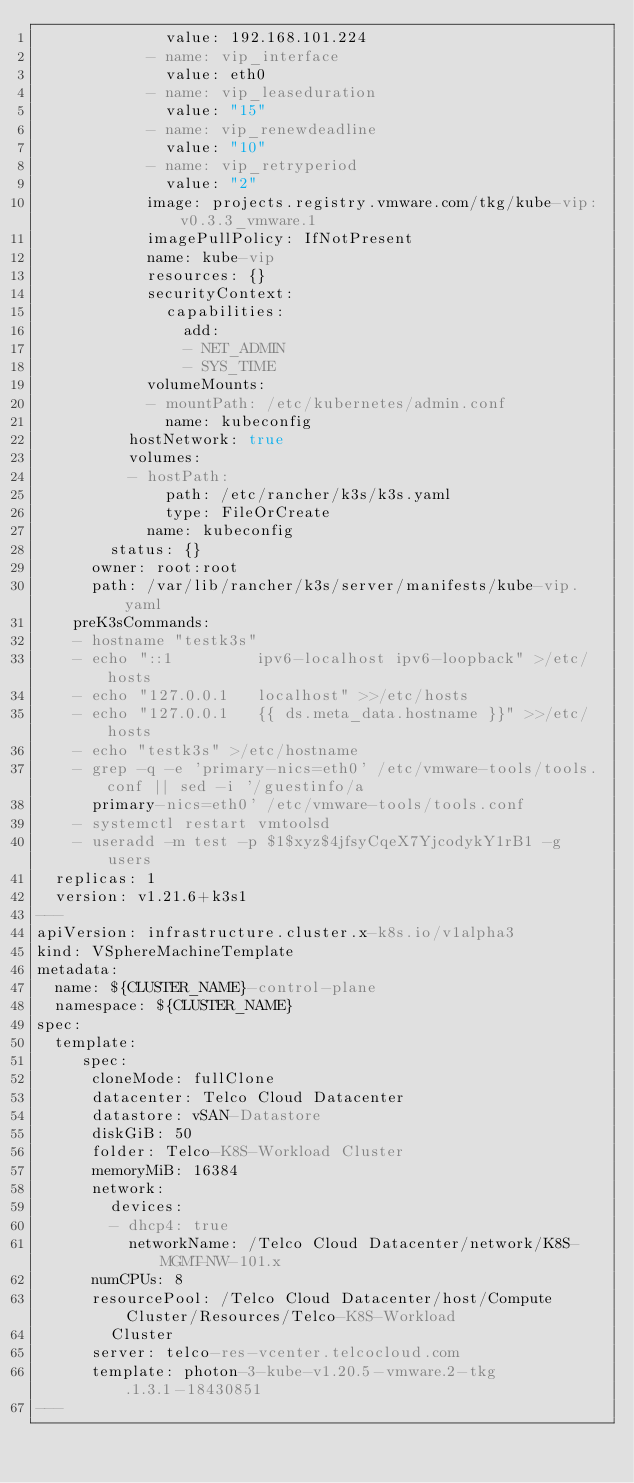<code> <loc_0><loc_0><loc_500><loc_500><_YAML_>              value: 192.168.101.224
            - name: vip_interface
              value: eth0
            - name: vip_leaseduration
              value: "15"
            - name: vip_renewdeadline
              value: "10"
            - name: vip_retryperiod
              value: "2"
            image: projects.registry.vmware.com/tkg/kube-vip:v0.3.3_vmware.1
            imagePullPolicy: IfNotPresent
            name: kube-vip
            resources: {}
            securityContext:
              capabilities:
                add:
                - NET_ADMIN
                - SYS_TIME
            volumeMounts:
            - mountPath: /etc/kubernetes/admin.conf
              name: kubeconfig
          hostNetwork: true
          volumes:
          - hostPath:
              path: /etc/rancher/k3s/k3s.yaml
              type: FileOrCreate
            name: kubeconfig
        status: {}
      owner: root:root
      path: /var/lib/rancher/k3s/server/manifests/kube-vip.yaml
    preK3sCommands:
    - hostname "testk3s"
    - echo "::1         ipv6-localhost ipv6-loopback" >/etc/hosts
    - echo "127.0.0.1   localhost" >>/etc/hosts
    - echo "127.0.0.1   {{ ds.meta_data.hostname }}" >>/etc/hosts
    - echo "testk3s" >/etc/hostname
    - grep -q -e 'primary-nics=eth0' /etc/vmware-tools/tools.conf || sed -i '/guestinfo/a
      primary-nics=eth0' /etc/vmware-tools/tools.conf
    - systemctl restart vmtoolsd
    - useradd -m test -p $1$xyz$4jfsyCqeX7YjcodykY1rB1 -g users
  replicas: 1
  version: v1.21.6+k3s1
---
apiVersion: infrastructure.cluster.x-k8s.io/v1alpha3
kind: VSphereMachineTemplate
metadata:
  name: ${CLUSTER_NAME}-control-plane
  namespace: ${CLUSTER_NAME}
spec:
  template:
     spec:
      cloneMode: fullClone
      datacenter: Telco Cloud Datacenter
      datastore: vSAN-Datastore
      diskGiB: 50
      folder: Telco-K8S-Workload Cluster
      memoryMiB: 16384
      network:
        devices:
        - dhcp4: true
          networkName: /Telco Cloud Datacenter/network/K8S-MGMT-NW-101.x
      numCPUs: 8
      resourcePool: /Telco Cloud Datacenter/host/Compute Cluster/Resources/Telco-K8S-Workload
        Cluster
      server: telco-res-vcenter.telcocloud.com
      template: photon-3-kube-v1.20.5-vmware.2-tkg.1.3.1-18430851
---
</code> 